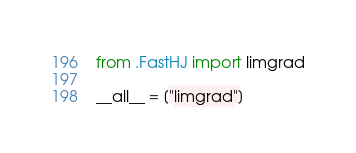Convert code to text. <code><loc_0><loc_0><loc_500><loc_500><_Python_>from .FastHJ import limgrad

__all__ = ["limgrad"]
</code> 